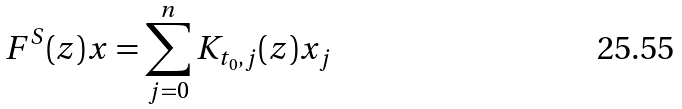Convert formula to latex. <formula><loc_0><loc_0><loc_500><loc_500>F ^ { S } ( z ) x = \sum _ { j = 0 } ^ { n } K _ { t _ { 0 } , j } ( z ) x _ { j }</formula> 